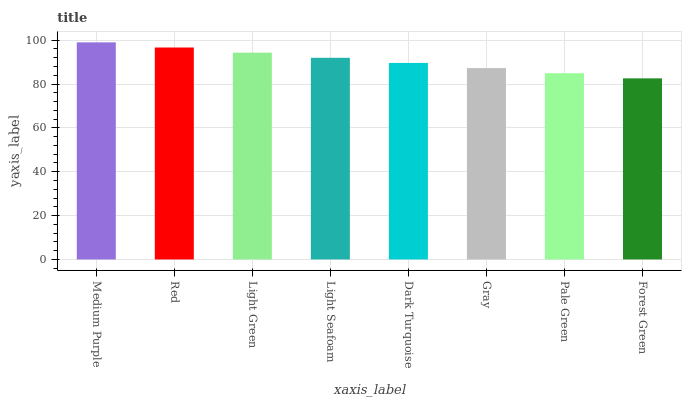Is Forest Green the minimum?
Answer yes or no. Yes. Is Medium Purple the maximum?
Answer yes or no. Yes. Is Red the minimum?
Answer yes or no. No. Is Red the maximum?
Answer yes or no. No. Is Medium Purple greater than Red?
Answer yes or no. Yes. Is Red less than Medium Purple?
Answer yes or no. Yes. Is Red greater than Medium Purple?
Answer yes or no. No. Is Medium Purple less than Red?
Answer yes or no. No. Is Light Seafoam the high median?
Answer yes or no. Yes. Is Dark Turquoise the low median?
Answer yes or no. Yes. Is Medium Purple the high median?
Answer yes or no. No. Is Forest Green the low median?
Answer yes or no. No. 